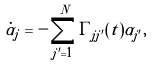Convert formula to latex. <formula><loc_0><loc_0><loc_500><loc_500>\dot { \alpha } _ { j } = - \sum _ { j ^ { \prime } = 1 } ^ { N } \Gamma _ { j j ^ { \prime } } ( t ) \alpha _ { j ^ { \prime } } ,</formula> 